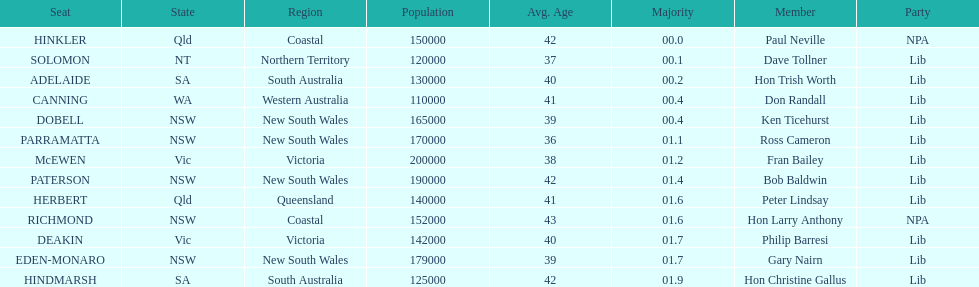How many members in total? 13. 